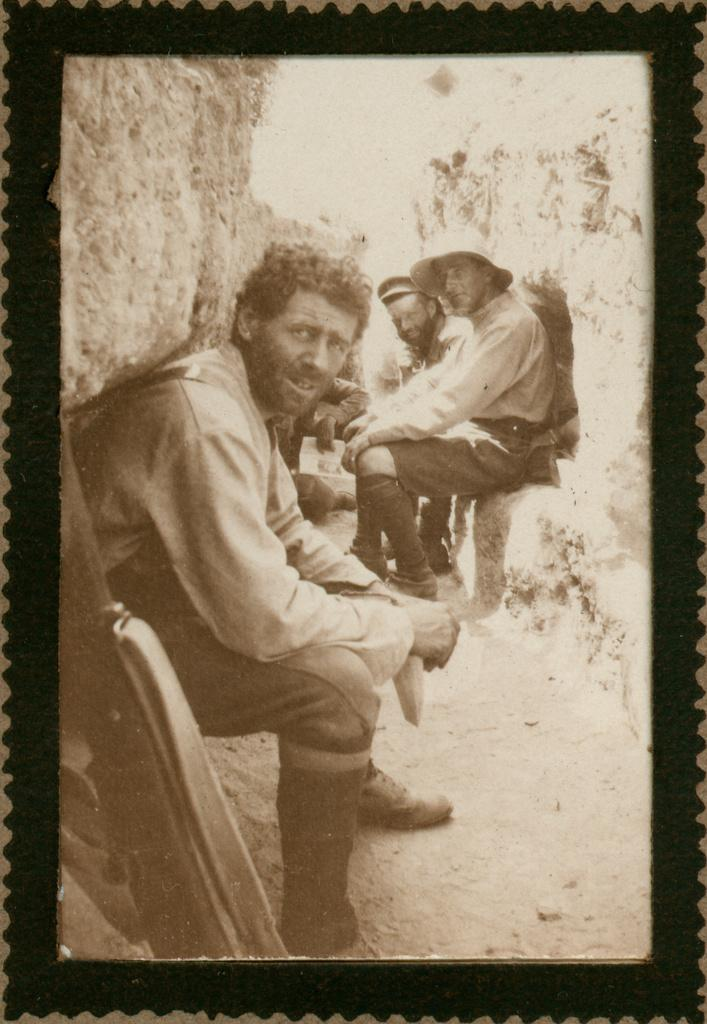Who or what can be seen in the image? There are people in the image. What are the people wearing? The people are wearing clothes. Can you describe the object in the bottom left of the image? Unfortunately, the provided facts do not give enough information to describe the object in the bottom left of the image. What hobbies do the people in the image have? The provided facts do not give any information about the hobbies of the people in the image. --- 